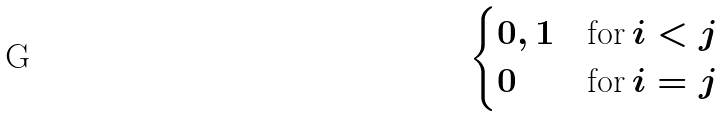Convert formula to latex. <formula><loc_0><loc_0><loc_500><loc_500>\begin{cases} 0 , 1 & \text {for} \, i < j \\ 0 & \text {for} \, i = j \end{cases}</formula> 